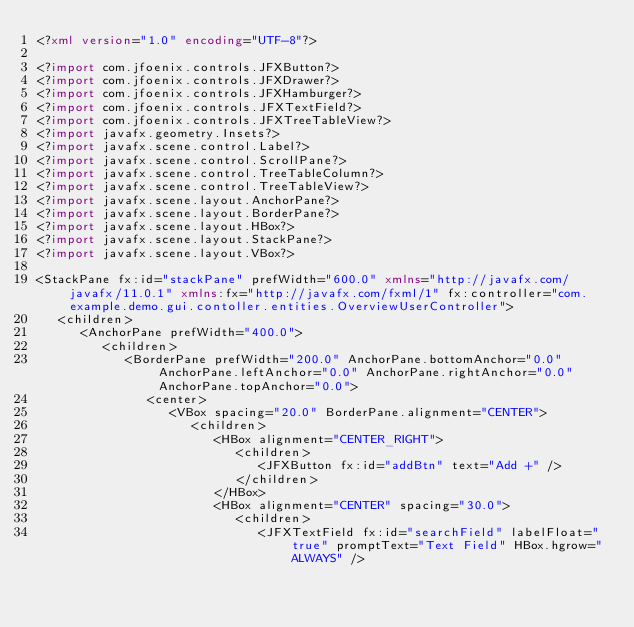<code> <loc_0><loc_0><loc_500><loc_500><_XML_><?xml version="1.0" encoding="UTF-8"?>

<?import com.jfoenix.controls.JFXButton?>
<?import com.jfoenix.controls.JFXDrawer?>
<?import com.jfoenix.controls.JFXHamburger?>
<?import com.jfoenix.controls.JFXTextField?>
<?import com.jfoenix.controls.JFXTreeTableView?>
<?import javafx.geometry.Insets?>
<?import javafx.scene.control.Label?>
<?import javafx.scene.control.ScrollPane?>
<?import javafx.scene.control.TreeTableColumn?>
<?import javafx.scene.control.TreeTableView?>
<?import javafx.scene.layout.AnchorPane?>
<?import javafx.scene.layout.BorderPane?>
<?import javafx.scene.layout.HBox?>
<?import javafx.scene.layout.StackPane?>
<?import javafx.scene.layout.VBox?>

<StackPane fx:id="stackPane" prefWidth="600.0" xmlns="http://javafx.com/javafx/11.0.1" xmlns:fx="http://javafx.com/fxml/1" fx:controller="com.example.demo.gui.contoller.entities.OverviewUserController">
   <children>
      <AnchorPane prefWidth="400.0">
         <children>
            <BorderPane prefWidth="200.0" AnchorPane.bottomAnchor="0.0" AnchorPane.leftAnchor="0.0" AnchorPane.rightAnchor="0.0" AnchorPane.topAnchor="0.0">
               <center>
                  <VBox spacing="20.0" BorderPane.alignment="CENTER">
                     <children>
                        <HBox alignment="CENTER_RIGHT">
                           <children>
                              <JFXButton fx:id="addBtn" text="Add +" />
                           </children>
                        </HBox>
                        <HBox alignment="CENTER" spacing="30.0">
                           <children>
                              <JFXTextField fx:id="searchField" labelFloat="true" promptText="Text Field" HBox.hgrow="ALWAYS" /></code> 